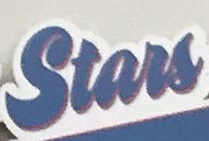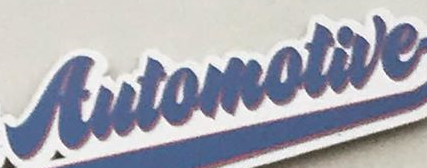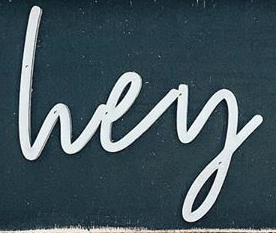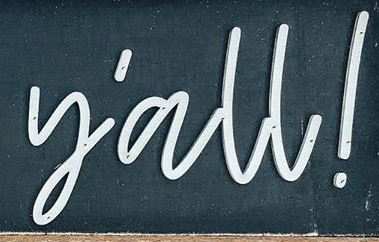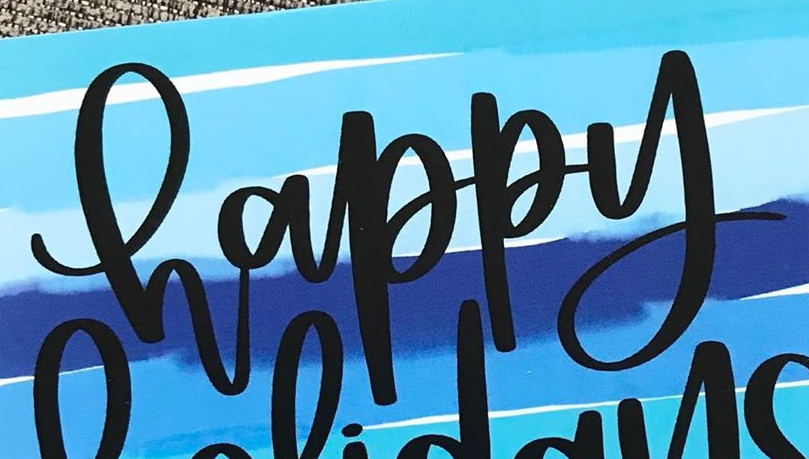Read the text content from these images in order, separated by a semicolon. Stars; Automotive; lvey; y'all!; happy 